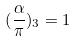<formula> <loc_0><loc_0><loc_500><loc_500>( \frac { \alpha } { \pi } ) _ { 3 } = 1</formula> 